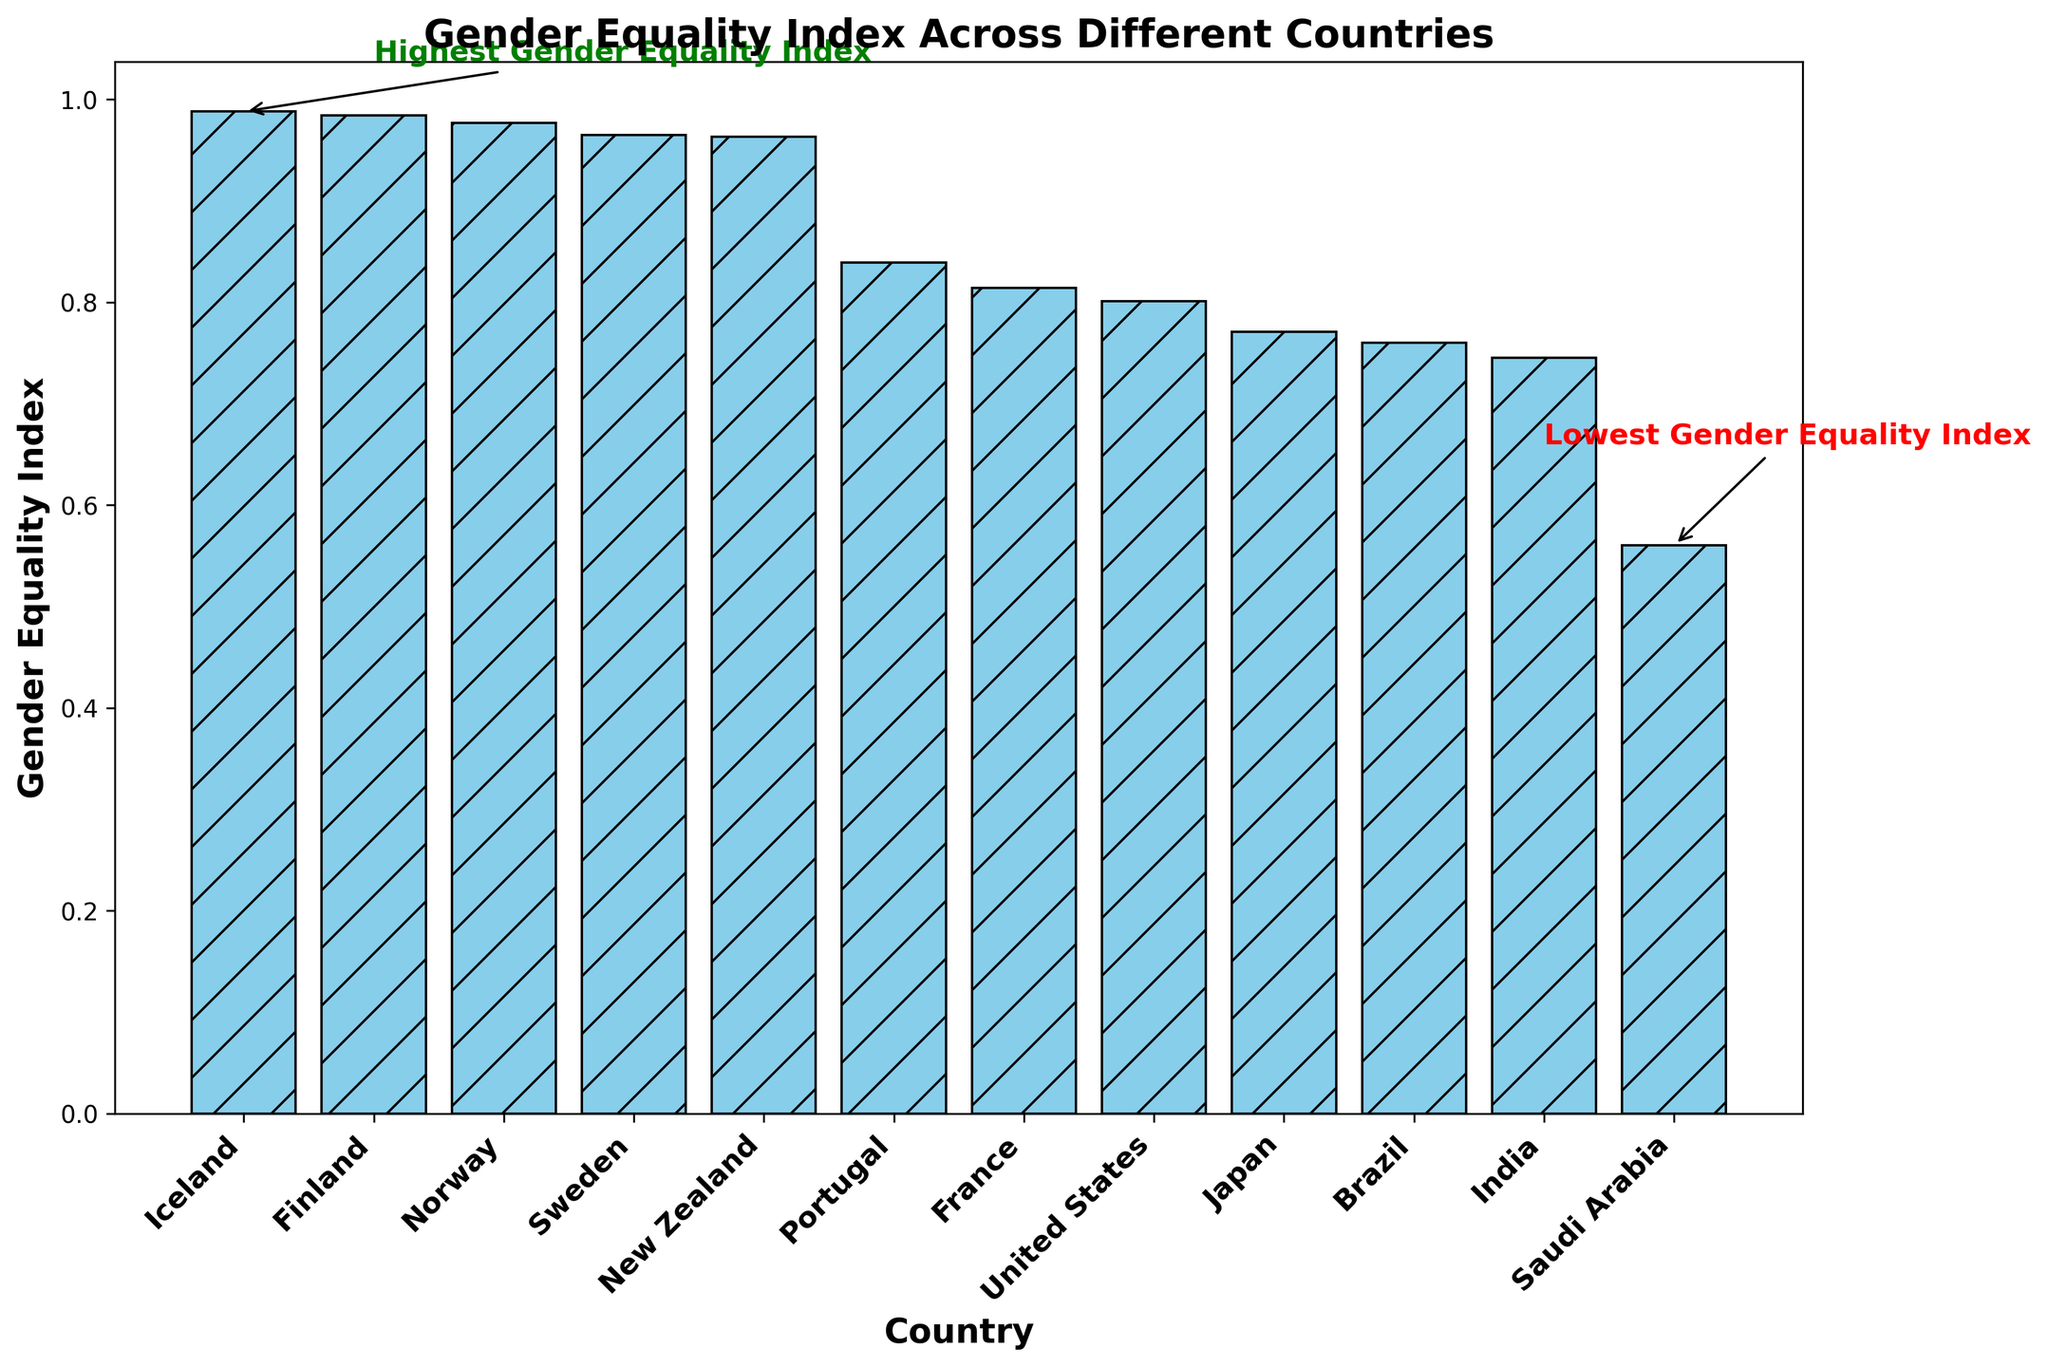Which country has the highest Gender Equality Index? The annotation "Highest Gender Equality Index" points to the highest bar in the figure corresponding to Iceland.
Answer: Iceland Which countries gained voting rights before 1920? From the plot and text annotations, countries such as Iceland, Finland, Norway, New Zealand, and Sweden gained voting rights before 1920.
Answer: Iceland, Finland, Norway, New Zealand, Sweden What is the difference in the Gender Equality Index between the country with the highest and the lowest index? Iceland has the highest index of 0.988 and Saudi Arabia has the lowest index of 0.560. The difference is 0.988 - 0.560.
Answer: 0.428 How does the Gender Equality Index of the United States compare to that of France? The bar for the United States is slightly higher than the bar for France.
Answer: The United States has a higher index than France Which country gained voting rights most recently and what is its Gender Equality Index? The annotation and data show that Saudi Arabia gained voting rights in 2015 and has a Gender Equality Index of 0.560.
Answer: Saudi Arabia, 0.560 Looking at the visual height of the bars, which country has better education access, Finland or New Zealand? Both bars are almost at the top; however, Finland has a slightly taller bar, indicating slightly better education access.
Answer: Finland What's the average Gender Equality Index of the top three countries? The top three countries by Gender Equality Index are Iceland (0.988), Finland (0.984), and Norway (0.977). The average is (0.988 + 0.984 + 0.977) / 3.
Answer: 0.983 What is the trend in Gender Equality Index for countries that gained voting rights before 1950 compared to those that gained voting rights after that? Countries that gained voting rights before 1950 tend to have higher Gender Equality Indexes than those that gained voting rights after 1950.
Answer: Higher Which country has a Gender Equality Index closest to 0.8? By comparing the bars, it can be seen that the United States has a Gender Equality Index closest to 0.8.
Answer: United States How does the education access in India compare to that in Brazil? The bar for education access in Brazil is visibly higher than that in India, indicating better education access in Brazil.
Answer: Brazil has better education access 